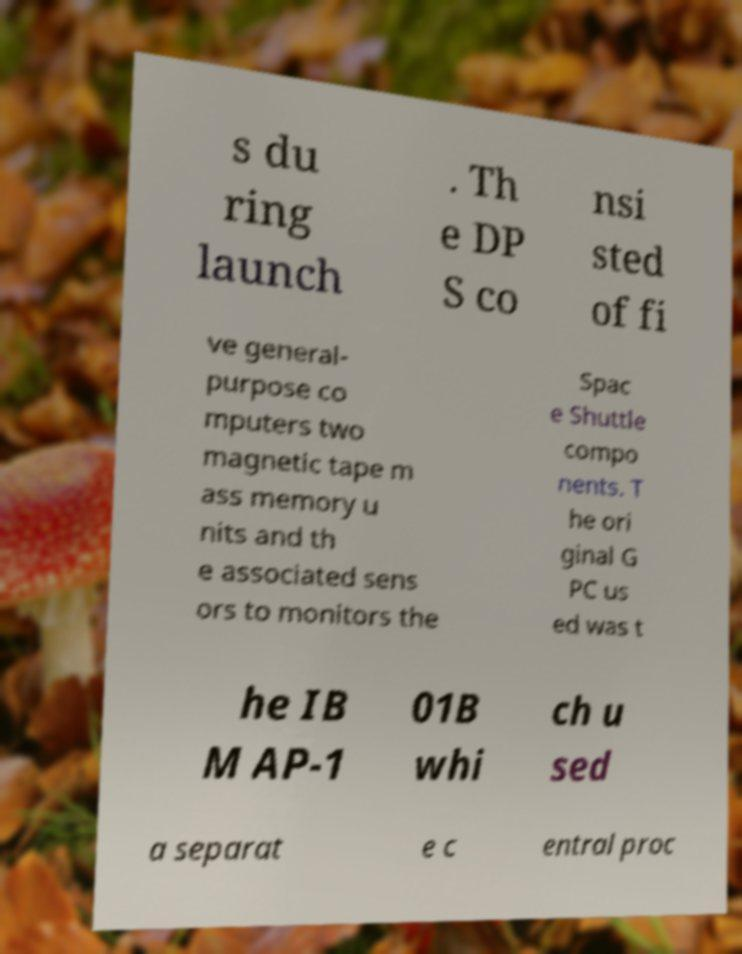For documentation purposes, I need the text within this image transcribed. Could you provide that? s du ring launch . Th e DP S co nsi sted of fi ve general- purpose co mputers two magnetic tape m ass memory u nits and th e associated sens ors to monitors the Spac e Shuttle compo nents. T he ori ginal G PC us ed was t he IB M AP-1 01B whi ch u sed a separat e c entral proc 